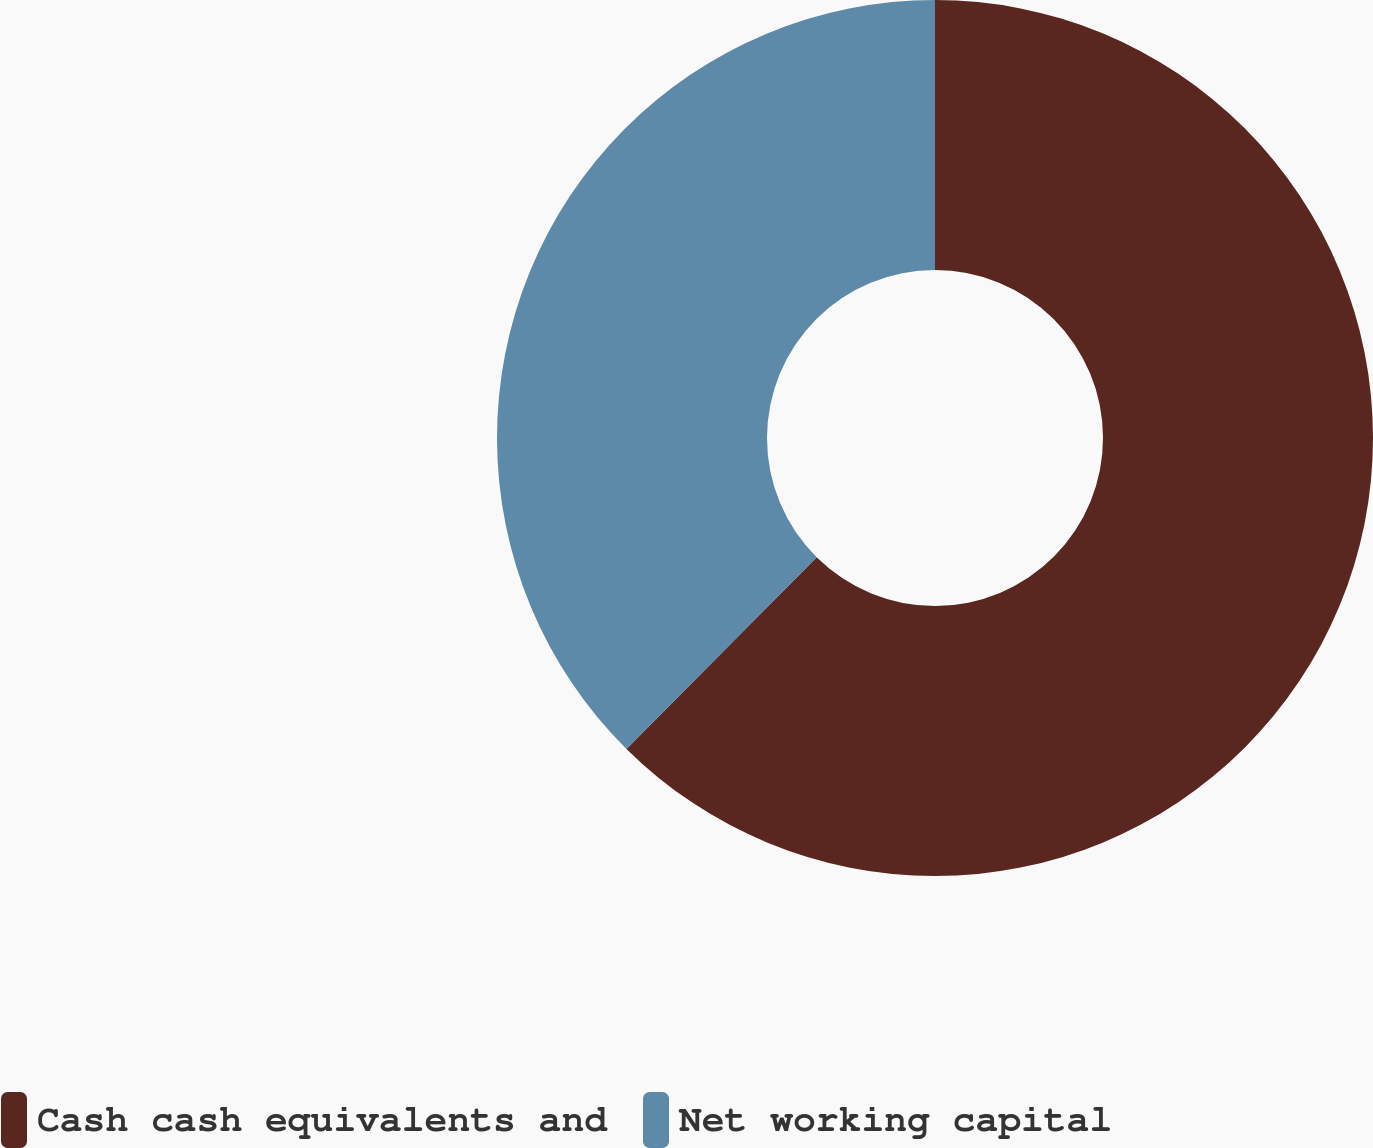<chart> <loc_0><loc_0><loc_500><loc_500><pie_chart><fcel>Cash cash equivalents and<fcel>Net working capital<nl><fcel>62.44%<fcel>37.56%<nl></chart> 